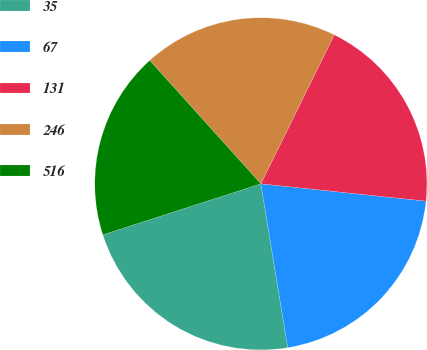Convert chart. <chart><loc_0><loc_0><loc_500><loc_500><pie_chart><fcel>35<fcel>67<fcel>131<fcel>246<fcel>516<nl><fcel>22.62%<fcel>20.75%<fcel>19.38%<fcel>18.95%<fcel>18.3%<nl></chart> 